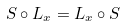<formula> <loc_0><loc_0><loc_500><loc_500>S \circ L _ { x } = L _ { x } \circ S</formula> 